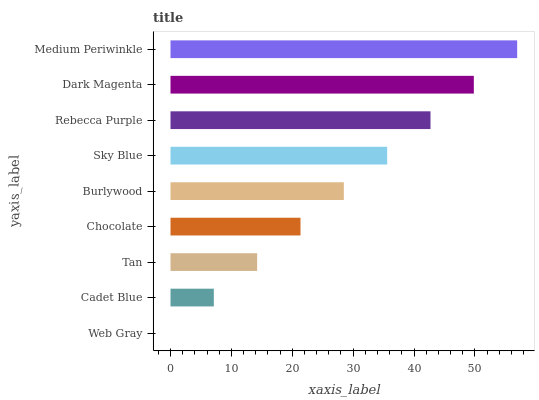Is Web Gray the minimum?
Answer yes or no. Yes. Is Medium Periwinkle the maximum?
Answer yes or no. Yes. Is Cadet Blue the minimum?
Answer yes or no. No. Is Cadet Blue the maximum?
Answer yes or no. No. Is Cadet Blue greater than Web Gray?
Answer yes or no. Yes. Is Web Gray less than Cadet Blue?
Answer yes or no. Yes. Is Web Gray greater than Cadet Blue?
Answer yes or no. No. Is Cadet Blue less than Web Gray?
Answer yes or no. No. Is Burlywood the high median?
Answer yes or no. Yes. Is Burlywood the low median?
Answer yes or no. Yes. Is Medium Periwinkle the high median?
Answer yes or no. No. Is Cadet Blue the low median?
Answer yes or no. No. 